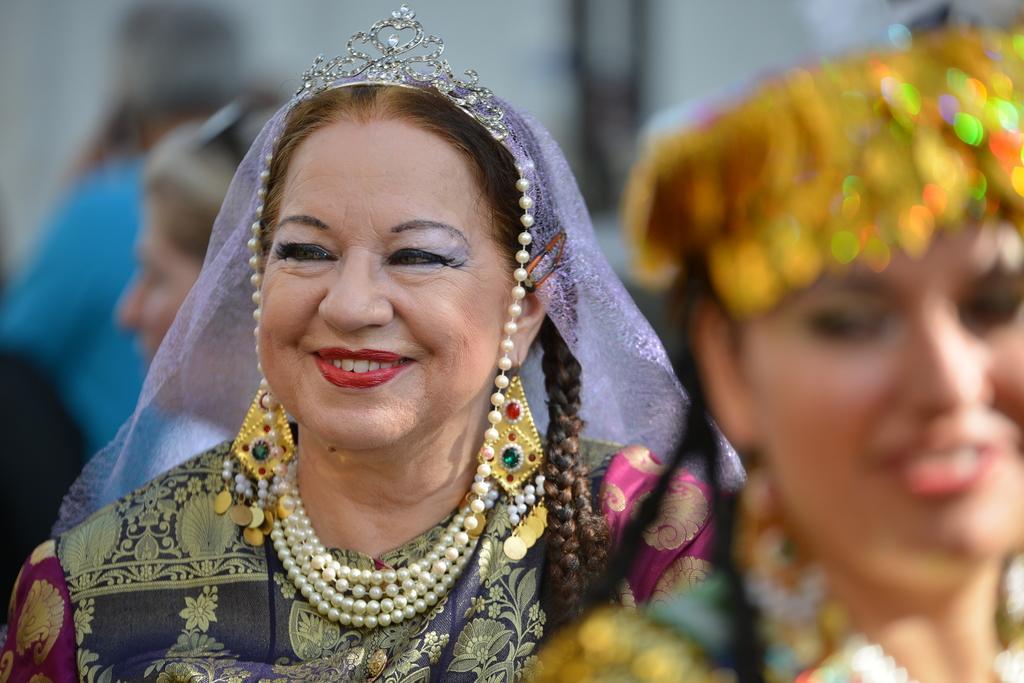Please provide a concise description of this image. In this image women are smiling. These women are wearing jewellery, necklace and other ornaments. The background of the image is blurred. 